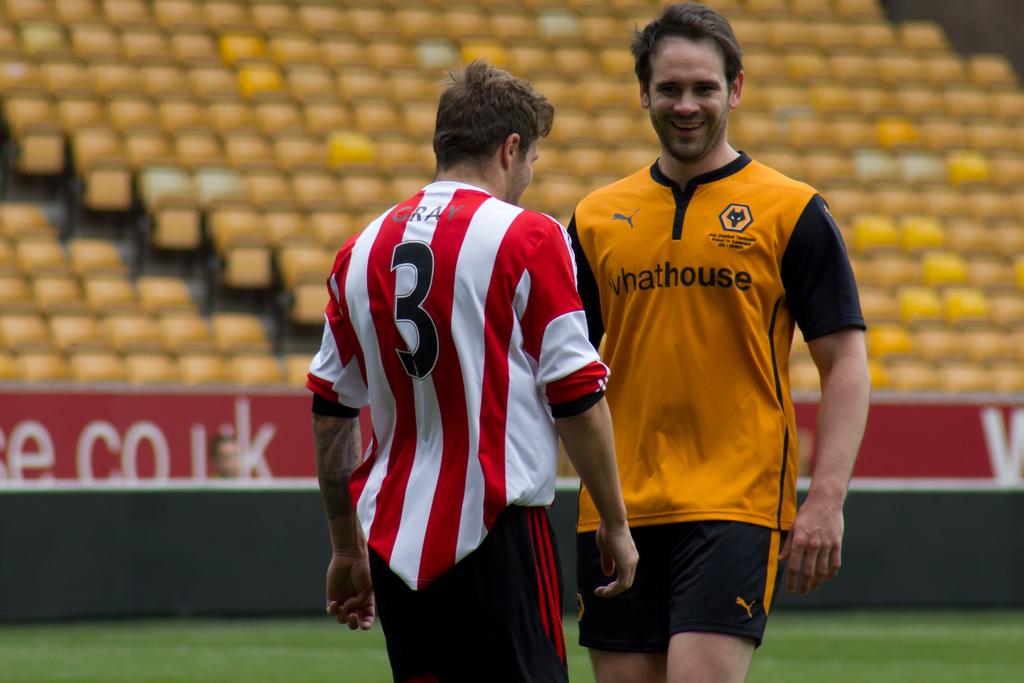Who is playing the game?
Your answer should be very brief. Gray. What is the players number in the red and white shirt?
Provide a short and direct response. 3. 